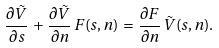Convert formula to latex. <formula><loc_0><loc_0><loc_500><loc_500>\frac { \partial \tilde { V } } { \partial s } \, + \, \frac { \partial \tilde { V } } { \partial n } \, F ( s , n ) \, = \, \frac { \partial F } { \partial n } \, \tilde { V } ( s , n ) .</formula> 